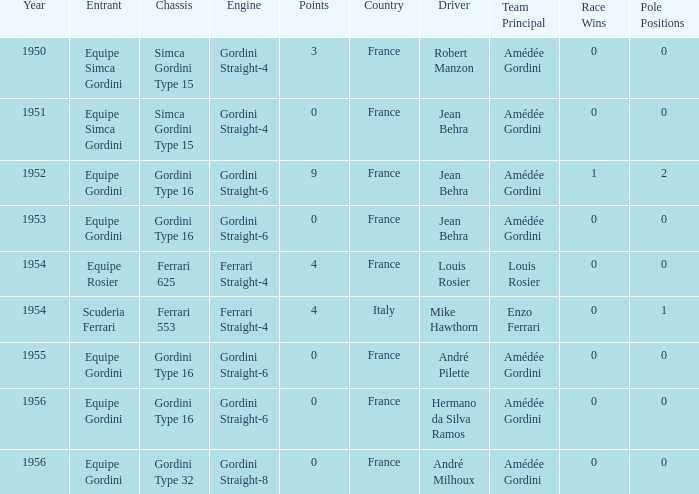How many points after 1956? 0.0. Can you give me this table as a dict? {'header': ['Year', 'Entrant', 'Chassis', 'Engine', 'Points', 'Country', 'Driver', 'Team Principal', 'Race Wins', 'Pole Positions '], 'rows': [['1950', 'Equipe Simca Gordini', 'Simca Gordini Type 15', 'Gordini Straight-4', '3', 'France', 'Robert Manzon', 'Amédée Gordini', '0', '0'], ['1951', 'Equipe Simca Gordini', 'Simca Gordini Type 15', 'Gordini Straight-4', '0', 'France', 'Jean Behra', 'Amédée Gordini', '0', '0'], ['1952', 'Equipe Gordini', 'Gordini Type 16', 'Gordini Straight-6', '9', 'France', 'Jean Behra', 'Amédée Gordini', '1', '2'], ['1953', 'Equipe Gordini', 'Gordini Type 16', 'Gordini Straight-6', '0', 'France', 'Jean Behra', 'Amédée Gordini', '0', '0'], ['1954', 'Equipe Rosier', 'Ferrari 625', 'Ferrari Straight-4', '4', 'France', 'Louis Rosier', 'Louis Rosier', '0', '0'], ['1954', 'Scuderia Ferrari', 'Ferrari 553', 'Ferrari Straight-4', '4', 'Italy', 'Mike Hawthorn', 'Enzo Ferrari', '0', '1'], ['1955', 'Equipe Gordini', 'Gordini Type 16', 'Gordini Straight-6', '0', 'France', 'André Pilette', 'Amédée Gordini', '0', '0'], ['1956', 'Equipe Gordini', 'Gordini Type 16', 'Gordini Straight-6', '0', 'France', 'Hermano da Silva Ramos', 'Amédée Gordini', '0', '0'], ['1956', 'Equipe Gordini', 'Gordini Type 32', 'Gordini Straight-8', '0', 'France', 'André Milhoux', 'Amédée Gordini', '0', '0']]} 